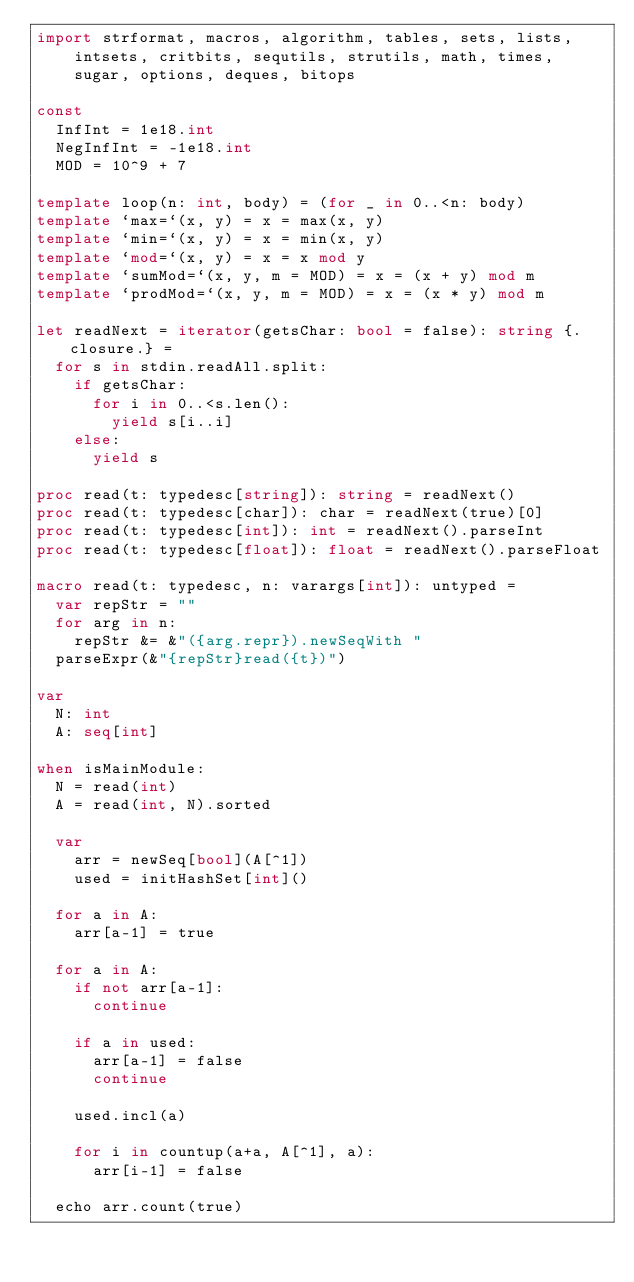Convert code to text. <code><loc_0><loc_0><loc_500><loc_500><_Nim_>import strformat, macros, algorithm, tables, sets, lists,
    intsets, critbits, sequtils, strutils, math, times,
    sugar, options, deques, bitops

const
  InfInt = 1e18.int
  NegInfInt = -1e18.int
  MOD = 10^9 + 7

template loop(n: int, body) = (for _ in 0..<n: body)
template `max=`(x, y) = x = max(x, y)
template `min=`(x, y) = x = min(x, y)
template `mod=`(x, y) = x = x mod y
template `sumMod=`(x, y, m = MOD) = x = (x + y) mod m
template `prodMod=`(x, y, m = MOD) = x = (x * y) mod m

let readNext = iterator(getsChar: bool = false): string {.closure.} =
  for s in stdin.readAll.split:
    if getsChar:
      for i in 0..<s.len():
        yield s[i..i]
    else:
      yield s

proc read(t: typedesc[string]): string = readNext()
proc read(t: typedesc[char]): char = readNext(true)[0]
proc read(t: typedesc[int]): int = readNext().parseInt
proc read(t: typedesc[float]): float = readNext().parseFloat

macro read(t: typedesc, n: varargs[int]): untyped =
  var repStr = ""
  for arg in n:
    repStr &= &"({arg.repr}).newSeqWith "
  parseExpr(&"{repStr}read({t})")

var
  N: int
  A: seq[int]

when isMainModule:
  N = read(int)
  A = read(int, N).sorted

  var
    arr = newSeq[bool](A[^1])
    used = initHashSet[int]()

  for a in A:
    arr[a-1] = true

  for a in A:
    if not arr[a-1]:
      continue

    if a in used:
      arr[a-1] = false
      continue

    used.incl(a)

    for i in countup(a+a, A[^1], a):
      arr[i-1] = false

  echo arr.count(true)
</code> 